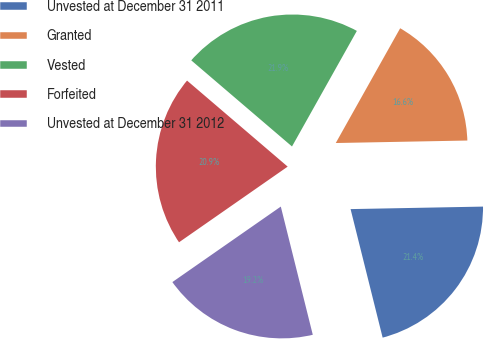<chart> <loc_0><loc_0><loc_500><loc_500><pie_chart><fcel>Unvested at December 31 2011<fcel>Granted<fcel>Vested<fcel>Forfeited<fcel>Unvested at December 31 2012<nl><fcel>21.41%<fcel>16.56%<fcel>21.88%<fcel>20.94%<fcel>19.21%<nl></chart> 